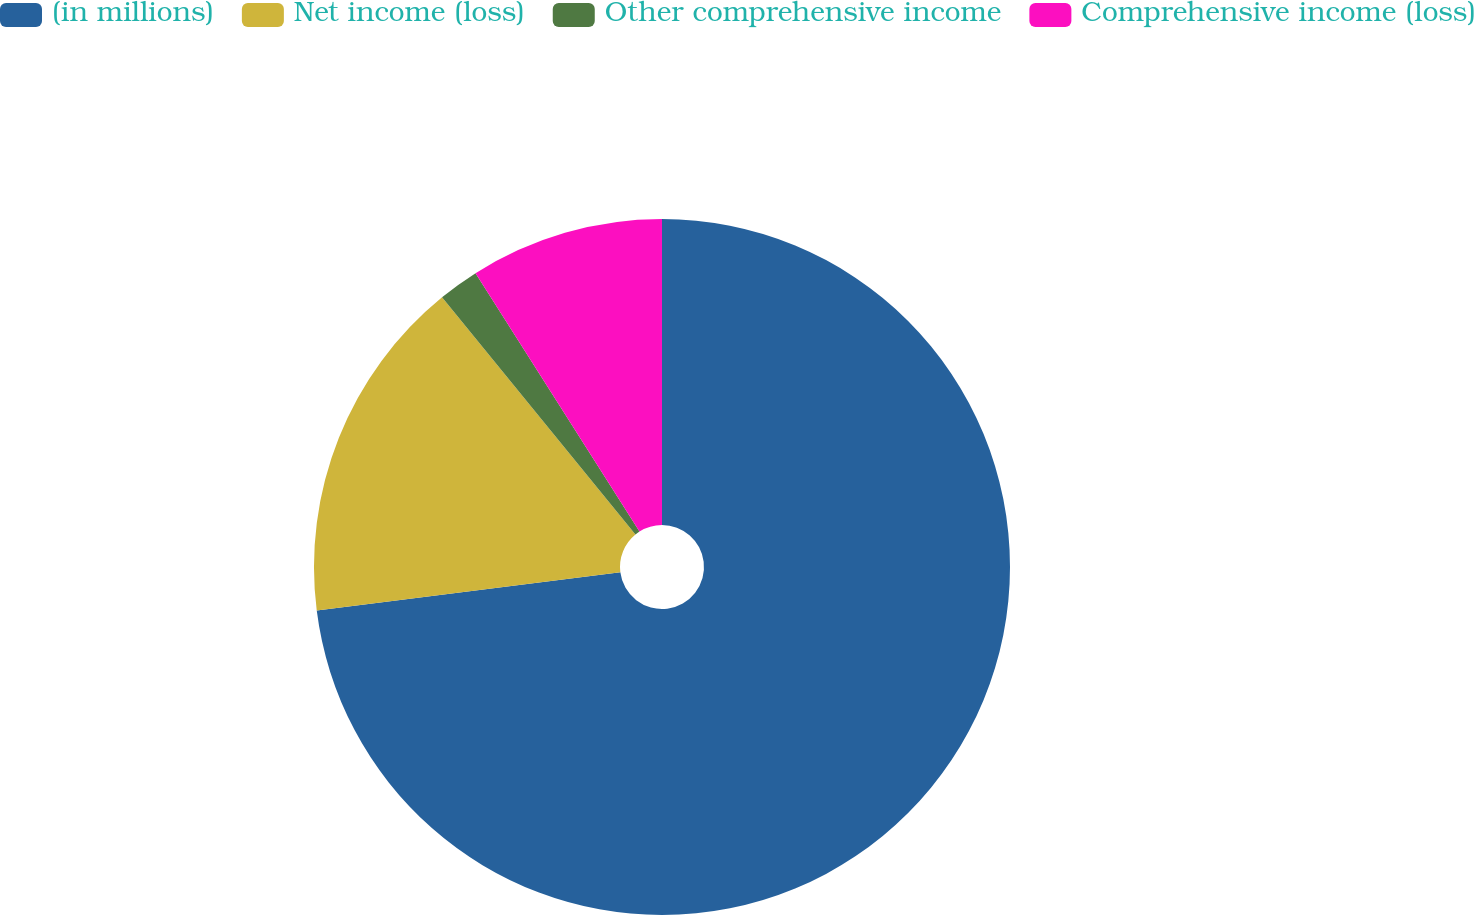Convert chart. <chart><loc_0><loc_0><loc_500><loc_500><pie_chart><fcel>(in millions)<fcel>Net income (loss)<fcel>Other comprehensive income<fcel>Comprehensive income (loss)<nl><fcel>73.0%<fcel>16.11%<fcel>1.89%<fcel>9.0%<nl></chart> 